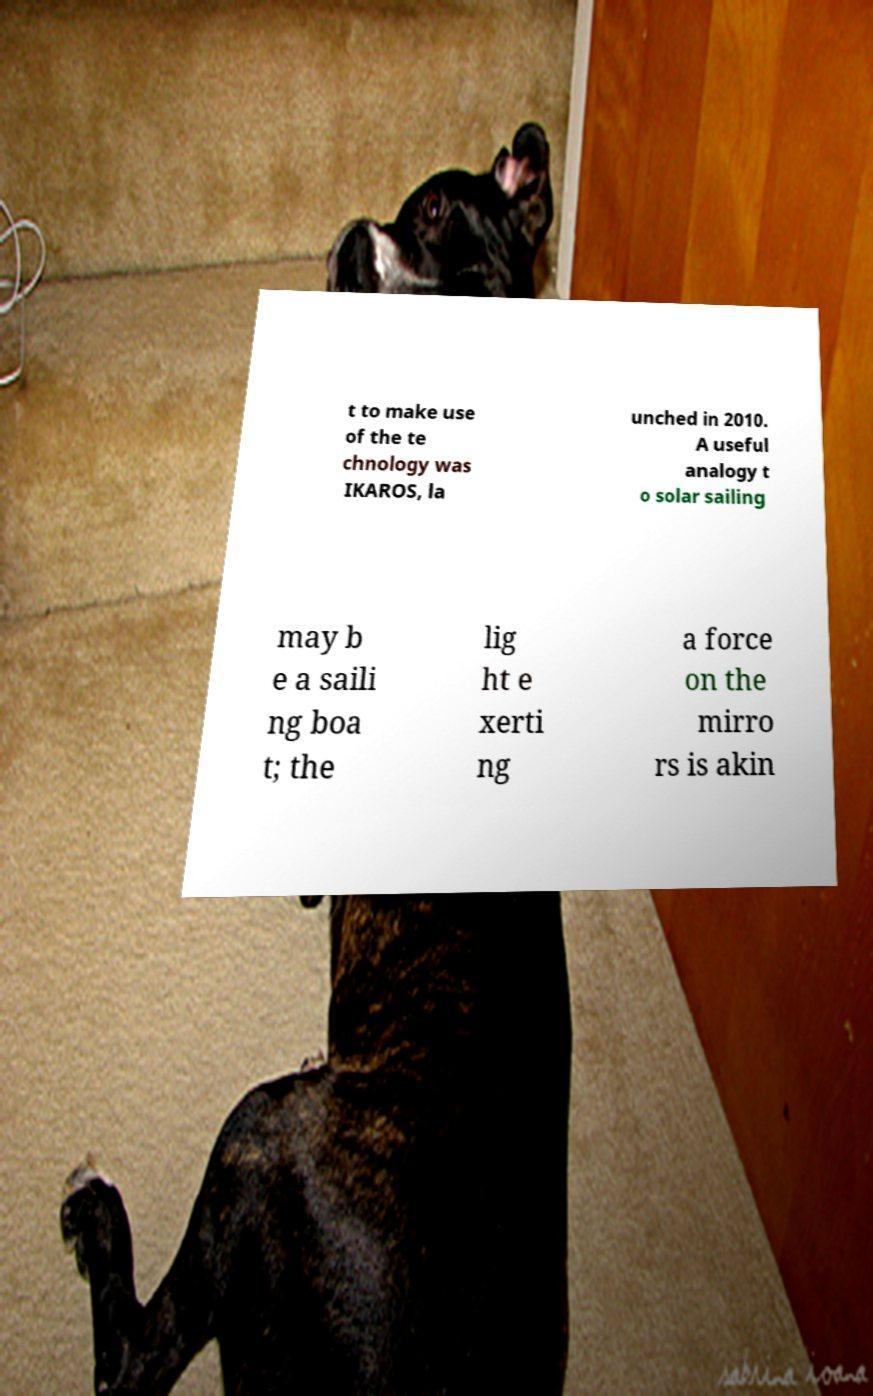I need the written content from this picture converted into text. Can you do that? t to make use of the te chnology was IKAROS, la unched in 2010. A useful analogy t o solar sailing may b e a saili ng boa t; the lig ht e xerti ng a force on the mirro rs is akin 